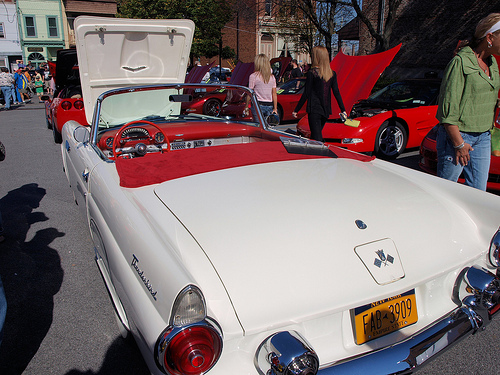<image>
Is there a shadow on the car? No. The shadow is not positioned on the car. They may be near each other, but the shadow is not supported by or resting on top of the car. Is there a woman in the car? No. The woman is not contained within the car. These objects have a different spatial relationship. Where is the car in relation to the car? Is it next to the car? No. The car is not positioned next to the car. They are located in different areas of the scene. 